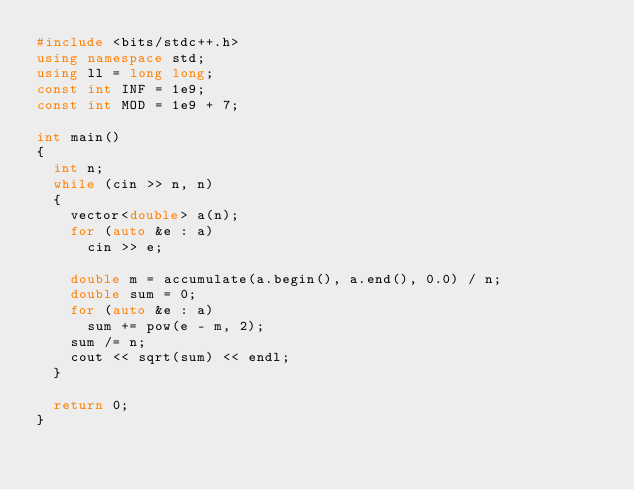Convert code to text. <code><loc_0><loc_0><loc_500><loc_500><_C++_>#include <bits/stdc++.h>
using namespace std;
using ll = long long;
const int INF = 1e9;
const int MOD = 1e9 + 7;

int main()
{
  int n;
  while (cin >> n, n)
  {
    vector<double> a(n);
    for (auto &e : a)
      cin >> e;

    double m = accumulate(a.begin(), a.end(), 0.0) / n;
    double sum = 0;
    for (auto &e : a)
      sum += pow(e - m, 2);
    sum /= n;
    cout << sqrt(sum) << endl;
  }

  return 0;
}

</code> 